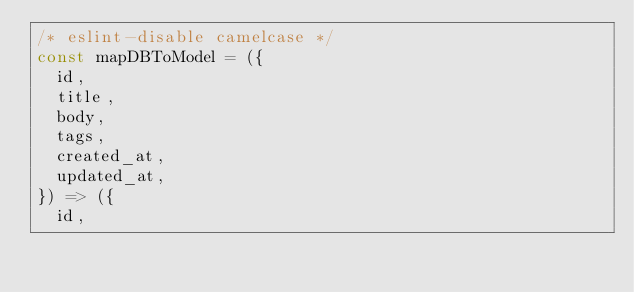Convert code to text. <code><loc_0><loc_0><loc_500><loc_500><_JavaScript_>/* eslint-disable camelcase */
const mapDBToModel = ({
  id,
  title,
  body,
  tags,
  created_at,
  updated_at,
}) => ({
  id,</code> 